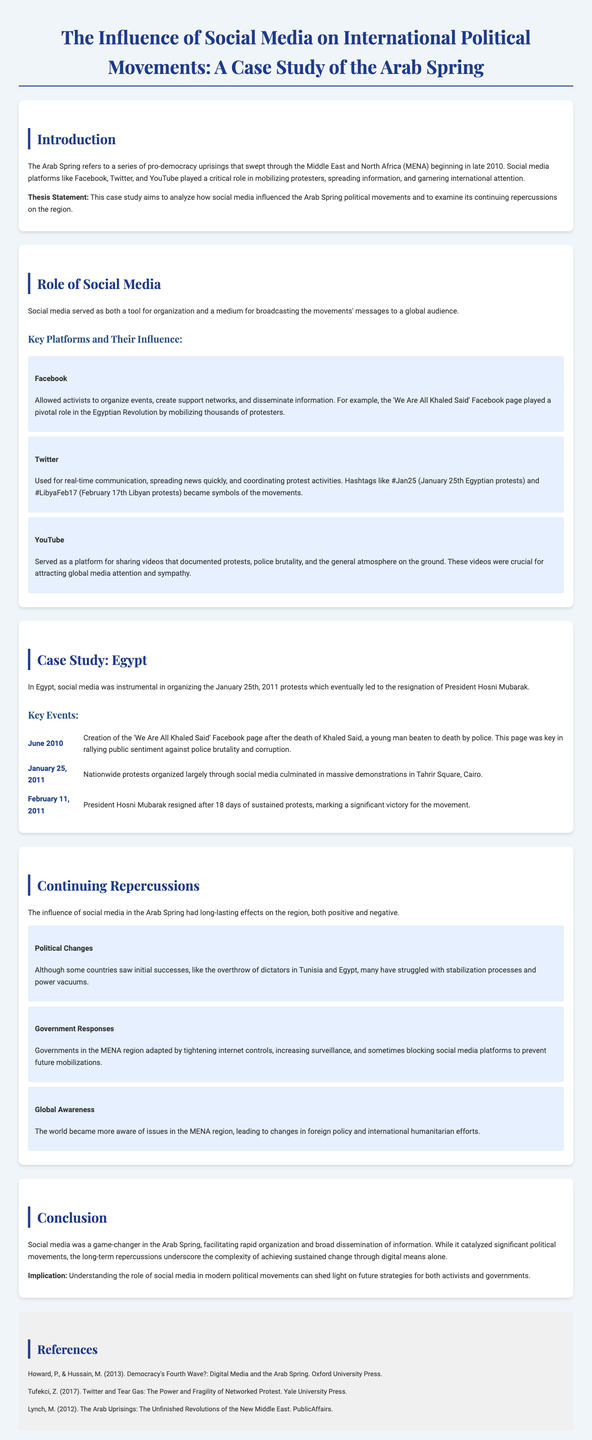what year did the Arab Spring begin? The document states that the Arab Spring began in late 2010.
Answer: 2010 what is the title of the key Facebook page mentioned? The document describes the 'We Are All Khaled Said' Facebook page as pivotal in the Egyptian Revolution.
Answer: We Are All Khaled Said which country is specifically highlighted in the case study? The case study focuses on Egypt as a primary example of the Arab Spring.
Answer: Egypt what significant event took place on February 11, 2011? According to the document, President Hosni Mubarak resigned after 18 days of sustained protests.
Answer: Mubarak resigned what was the role of YouTube in the Arab Spring? The document notes that YouTube served as a platform for sharing videos that documented protests and police brutality.
Answer: Sharing videos what impact did social media have on governmental responses in the MENA region? Governments adapted by tightening internet controls and increasing surveillance according to the document.
Answer: Tightening internet controls what effect did the Arab Spring have on international awareness? The document states that the world became more aware of issues in the MENA region due to the Arab Spring.
Answer: Increased awareness what is described as a significant consequence of the Arab Spring? The text outlines that many countries have struggled with stabilization processes and power vacuums since the uprisings.
Answer: Power vacuums 